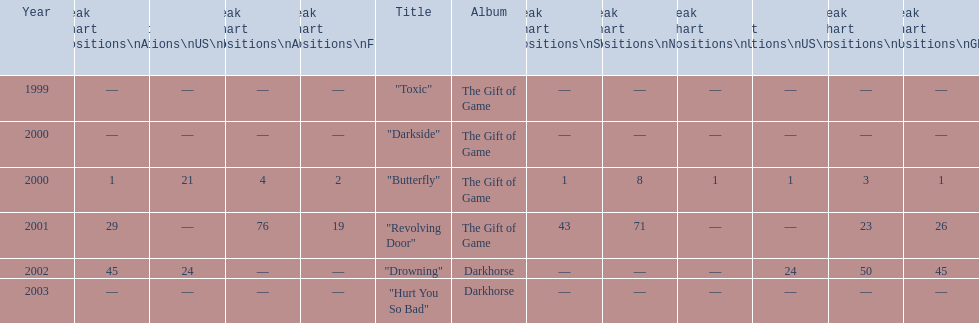Parse the table in full. {'header': ['Year', 'Peak chart positions\\nAUT', 'Peak chart positions\\nUS\\nMain. Rock', 'Peak chart positions\\nAUS', 'Peak chart positions\\nFIN', 'Title', 'Album', 'Peak chart positions\\nSWI', 'Peak chart positions\\nNLD', 'Peak chart positions\\nUS', 'Peak chart positions\\nUS\\nAlt.', 'Peak chart positions\\nUK', 'Peak chart positions\\nGER'], 'rows': [['1999', '—', '—', '—', '—', '"Toxic"', 'The Gift of Game', '—', '—', '—', '—', '—', '—'], ['2000', '—', '—', '—', '—', '"Darkside"', 'The Gift of Game', '—', '—', '—', '—', '—', '—'], ['2000', '1', '21', '4', '2', '"Butterfly"', 'The Gift of Game', '1', '8', '1', '1', '3', '1'], ['2001', '29', '—', '76', '19', '"Revolving Door"', 'The Gift of Game', '43', '71', '—', '—', '23', '26'], ['2002', '45', '24', '—', '—', '"Drowning"', 'Darkhorse', '—', '—', '—', '24', '50', '45'], ['2003', '—', '—', '—', '—', '"Hurt You So Bad"', 'Darkhorse', '—', '—', '—', '—', '—', '—']]} When did "drowning" peak at 24 in the us alternate group? 2002. 